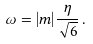Convert formula to latex. <formula><loc_0><loc_0><loc_500><loc_500>\omega = | m | \frac { \eta } { \sqrt { 6 } } \, .</formula> 